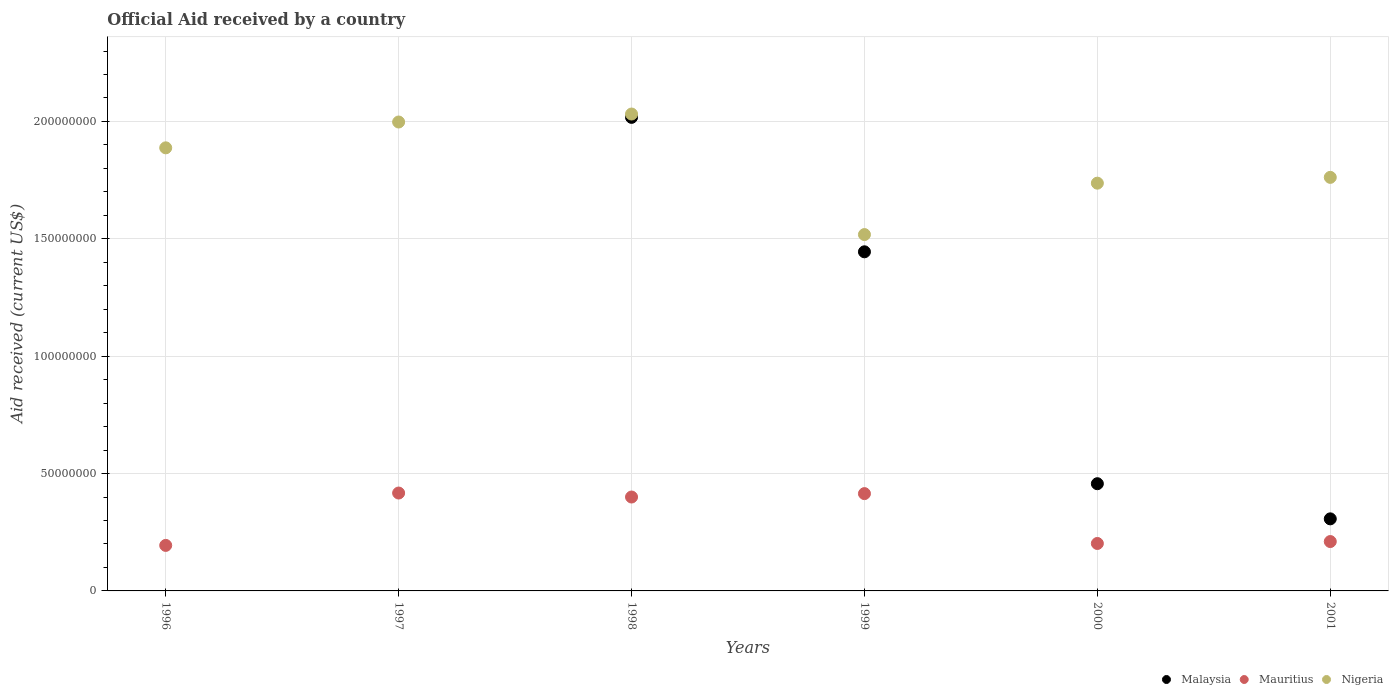Is the number of dotlines equal to the number of legend labels?
Make the answer very short. No. What is the net official aid received in Malaysia in 1998?
Provide a short and direct response. 2.02e+08. Across all years, what is the maximum net official aid received in Malaysia?
Provide a succinct answer. 2.02e+08. Across all years, what is the minimum net official aid received in Malaysia?
Make the answer very short. 0. What is the total net official aid received in Nigeria in the graph?
Give a very brief answer. 1.09e+09. What is the difference between the net official aid received in Malaysia in 1998 and that in 2000?
Ensure brevity in your answer.  1.56e+08. What is the difference between the net official aid received in Mauritius in 1998 and the net official aid received in Malaysia in 1997?
Give a very brief answer. 4.00e+07. What is the average net official aid received in Malaysia per year?
Your answer should be very brief. 7.04e+07. In the year 1999, what is the difference between the net official aid received in Malaysia and net official aid received in Nigeria?
Your answer should be very brief. -7.34e+06. What is the ratio of the net official aid received in Mauritius in 2000 to that in 2001?
Give a very brief answer. 0.96. Is the difference between the net official aid received in Malaysia in 2000 and 2001 greater than the difference between the net official aid received in Nigeria in 2000 and 2001?
Your answer should be very brief. Yes. What is the difference between the highest and the second highest net official aid received in Malaysia?
Provide a succinct answer. 5.73e+07. What is the difference between the highest and the lowest net official aid received in Mauritius?
Provide a short and direct response. 2.23e+07. Is the sum of the net official aid received in Nigeria in 1998 and 2000 greater than the maximum net official aid received in Mauritius across all years?
Make the answer very short. Yes. Does the net official aid received in Mauritius monotonically increase over the years?
Provide a succinct answer. No. How many dotlines are there?
Offer a very short reply. 3. What is the difference between two consecutive major ticks on the Y-axis?
Ensure brevity in your answer.  5.00e+07. Are the values on the major ticks of Y-axis written in scientific E-notation?
Offer a very short reply. No. What is the title of the graph?
Offer a terse response. Official Aid received by a country. Does "Chile" appear as one of the legend labels in the graph?
Offer a terse response. No. What is the label or title of the X-axis?
Your answer should be compact. Years. What is the label or title of the Y-axis?
Provide a short and direct response. Aid received (current US$). What is the Aid received (current US$) in Malaysia in 1996?
Keep it short and to the point. 0. What is the Aid received (current US$) of Mauritius in 1996?
Ensure brevity in your answer.  1.94e+07. What is the Aid received (current US$) of Nigeria in 1996?
Offer a terse response. 1.89e+08. What is the Aid received (current US$) in Mauritius in 1997?
Your answer should be compact. 4.17e+07. What is the Aid received (current US$) of Nigeria in 1997?
Provide a short and direct response. 2.00e+08. What is the Aid received (current US$) in Malaysia in 1998?
Your response must be concise. 2.02e+08. What is the Aid received (current US$) of Mauritius in 1998?
Provide a succinct answer. 4.00e+07. What is the Aid received (current US$) in Nigeria in 1998?
Provide a short and direct response. 2.03e+08. What is the Aid received (current US$) of Malaysia in 1999?
Your answer should be very brief. 1.44e+08. What is the Aid received (current US$) in Mauritius in 1999?
Keep it short and to the point. 4.14e+07. What is the Aid received (current US$) in Nigeria in 1999?
Offer a terse response. 1.52e+08. What is the Aid received (current US$) in Malaysia in 2000?
Provide a short and direct response. 4.57e+07. What is the Aid received (current US$) of Mauritius in 2000?
Offer a very short reply. 2.02e+07. What is the Aid received (current US$) in Nigeria in 2000?
Your answer should be compact. 1.74e+08. What is the Aid received (current US$) of Malaysia in 2001?
Offer a terse response. 3.07e+07. What is the Aid received (current US$) in Mauritius in 2001?
Make the answer very short. 2.10e+07. What is the Aid received (current US$) in Nigeria in 2001?
Ensure brevity in your answer.  1.76e+08. Across all years, what is the maximum Aid received (current US$) in Malaysia?
Your answer should be compact. 2.02e+08. Across all years, what is the maximum Aid received (current US$) of Mauritius?
Ensure brevity in your answer.  4.17e+07. Across all years, what is the maximum Aid received (current US$) in Nigeria?
Provide a short and direct response. 2.03e+08. Across all years, what is the minimum Aid received (current US$) in Malaysia?
Ensure brevity in your answer.  0. Across all years, what is the minimum Aid received (current US$) of Mauritius?
Make the answer very short. 1.94e+07. Across all years, what is the minimum Aid received (current US$) in Nigeria?
Your answer should be compact. 1.52e+08. What is the total Aid received (current US$) in Malaysia in the graph?
Your answer should be compact. 4.23e+08. What is the total Aid received (current US$) of Mauritius in the graph?
Offer a very short reply. 1.84e+08. What is the total Aid received (current US$) in Nigeria in the graph?
Give a very brief answer. 1.09e+09. What is the difference between the Aid received (current US$) in Mauritius in 1996 and that in 1997?
Give a very brief answer. -2.23e+07. What is the difference between the Aid received (current US$) in Nigeria in 1996 and that in 1997?
Ensure brevity in your answer.  -1.10e+07. What is the difference between the Aid received (current US$) in Mauritius in 1996 and that in 1998?
Offer a very short reply. -2.06e+07. What is the difference between the Aid received (current US$) of Nigeria in 1996 and that in 1998?
Provide a succinct answer. -1.44e+07. What is the difference between the Aid received (current US$) in Mauritius in 1996 and that in 1999?
Provide a short and direct response. -2.21e+07. What is the difference between the Aid received (current US$) of Nigeria in 1996 and that in 1999?
Your answer should be compact. 3.70e+07. What is the difference between the Aid received (current US$) of Mauritius in 1996 and that in 2000?
Provide a succinct answer. -8.20e+05. What is the difference between the Aid received (current US$) in Nigeria in 1996 and that in 2000?
Your answer should be very brief. 1.50e+07. What is the difference between the Aid received (current US$) in Mauritius in 1996 and that in 2001?
Offer a terse response. -1.64e+06. What is the difference between the Aid received (current US$) of Nigeria in 1996 and that in 2001?
Ensure brevity in your answer.  1.26e+07. What is the difference between the Aid received (current US$) of Mauritius in 1997 and that in 1998?
Your response must be concise. 1.70e+06. What is the difference between the Aid received (current US$) in Nigeria in 1997 and that in 1998?
Give a very brief answer. -3.40e+06. What is the difference between the Aid received (current US$) of Mauritius in 1997 and that in 1999?
Your response must be concise. 2.50e+05. What is the difference between the Aid received (current US$) in Nigeria in 1997 and that in 1999?
Provide a short and direct response. 4.80e+07. What is the difference between the Aid received (current US$) of Mauritius in 1997 and that in 2000?
Your response must be concise. 2.15e+07. What is the difference between the Aid received (current US$) of Nigeria in 1997 and that in 2000?
Your response must be concise. 2.60e+07. What is the difference between the Aid received (current US$) of Mauritius in 1997 and that in 2001?
Make the answer very short. 2.07e+07. What is the difference between the Aid received (current US$) of Nigeria in 1997 and that in 2001?
Provide a succinct answer. 2.36e+07. What is the difference between the Aid received (current US$) of Malaysia in 1998 and that in 1999?
Provide a short and direct response. 5.73e+07. What is the difference between the Aid received (current US$) of Mauritius in 1998 and that in 1999?
Ensure brevity in your answer.  -1.45e+06. What is the difference between the Aid received (current US$) of Nigeria in 1998 and that in 1999?
Keep it short and to the point. 5.14e+07. What is the difference between the Aid received (current US$) in Malaysia in 1998 and that in 2000?
Keep it short and to the point. 1.56e+08. What is the difference between the Aid received (current US$) of Mauritius in 1998 and that in 2000?
Your response must be concise. 1.98e+07. What is the difference between the Aid received (current US$) of Nigeria in 1998 and that in 2000?
Your response must be concise. 2.94e+07. What is the difference between the Aid received (current US$) of Malaysia in 1998 and that in 2001?
Your response must be concise. 1.71e+08. What is the difference between the Aid received (current US$) in Mauritius in 1998 and that in 2001?
Provide a succinct answer. 1.90e+07. What is the difference between the Aid received (current US$) in Nigeria in 1998 and that in 2001?
Ensure brevity in your answer.  2.70e+07. What is the difference between the Aid received (current US$) of Malaysia in 1999 and that in 2000?
Your answer should be compact. 9.88e+07. What is the difference between the Aid received (current US$) in Mauritius in 1999 and that in 2000?
Your answer should be very brief. 2.12e+07. What is the difference between the Aid received (current US$) of Nigeria in 1999 and that in 2000?
Keep it short and to the point. -2.19e+07. What is the difference between the Aid received (current US$) in Malaysia in 1999 and that in 2001?
Make the answer very short. 1.14e+08. What is the difference between the Aid received (current US$) of Mauritius in 1999 and that in 2001?
Give a very brief answer. 2.04e+07. What is the difference between the Aid received (current US$) of Nigeria in 1999 and that in 2001?
Your answer should be compact. -2.44e+07. What is the difference between the Aid received (current US$) of Malaysia in 2000 and that in 2001?
Give a very brief answer. 1.50e+07. What is the difference between the Aid received (current US$) of Mauritius in 2000 and that in 2001?
Keep it short and to the point. -8.20e+05. What is the difference between the Aid received (current US$) in Nigeria in 2000 and that in 2001?
Your response must be concise. -2.47e+06. What is the difference between the Aid received (current US$) in Mauritius in 1996 and the Aid received (current US$) in Nigeria in 1997?
Your answer should be compact. -1.80e+08. What is the difference between the Aid received (current US$) in Mauritius in 1996 and the Aid received (current US$) in Nigeria in 1998?
Keep it short and to the point. -1.84e+08. What is the difference between the Aid received (current US$) of Mauritius in 1996 and the Aid received (current US$) of Nigeria in 1999?
Ensure brevity in your answer.  -1.32e+08. What is the difference between the Aid received (current US$) in Mauritius in 1996 and the Aid received (current US$) in Nigeria in 2000?
Your response must be concise. -1.54e+08. What is the difference between the Aid received (current US$) in Mauritius in 1996 and the Aid received (current US$) in Nigeria in 2001?
Make the answer very short. -1.57e+08. What is the difference between the Aid received (current US$) in Mauritius in 1997 and the Aid received (current US$) in Nigeria in 1998?
Give a very brief answer. -1.61e+08. What is the difference between the Aid received (current US$) in Mauritius in 1997 and the Aid received (current US$) in Nigeria in 1999?
Your answer should be compact. -1.10e+08. What is the difference between the Aid received (current US$) of Mauritius in 1997 and the Aid received (current US$) of Nigeria in 2000?
Your answer should be very brief. -1.32e+08. What is the difference between the Aid received (current US$) of Mauritius in 1997 and the Aid received (current US$) of Nigeria in 2001?
Your answer should be very brief. -1.34e+08. What is the difference between the Aid received (current US$) of Malaysia in 1998 and the Aid received (current US$) of Mauritius in 1999?
Offer a very short reply. 1.60e+08. What is the difference between the Aid received (current US$) of Malaysia in 1998 and the Aid received (current US$) of Nigeria in 1999?
Your answer should be compact. 4.99e+07. What is the difference between the Aid received (current US$) in Mauritius in 1998 and the Aid received (current US$) in Nigeria in 1999?
Give a very brief answer. -1.12e+08. What is the difference between the Aid received (current US$) in Malaysia in 1998 and the Aid received (current US$) in Mauritius in 2000?
Your answer should be compact. 1.82e+08. What is the difference between the Aid received (current US$) of Malaysia in 1998 and the Aid received (current US$) of Nigeria in 2000?
Ensure brevity in your answer.  2.80e+07. What is the difference between the Aid received (current US$) in Mauritius in 1998 and the Aid received (current US$) in Nigeria in 2000?
Provide a short and direct response. -1.34e+08. What is the difference between the Aid received (current US$) in Malaysia in 1998 and the Aid received (current US$) in Mauritius in 2001?
Provide a short and direct response. 1.81e+08. What is the difference between the Aid received (current US$) in Malaysia in 1998 and the Aid received (current US$) in Nigeria in 2001?
Your response must be concise. 2.56e+07. What is the difference between the Aid received (current US$) in Mauritius in 1998 and the Aid received (current US$) in Nigeria in 2001?
Your answer should be very brief. -1.36e+08. What is the difference between the Aid received (current US$) of Malaysia in 1999 and the Aid received (current US$) of Mauritius in 2000?
Make the answer very short. 1.24e+08. What is the difference between the Aid received (current US$) of Malaysia in 1999 and the Aid received (current US$) of Nigeria in 2000?
Ensure brevity in your answer.  -2.92e+07. What is the difference between the Aid received (current US$) of Mauritius in 1999 and the Aid received (current US$) of Nigeria in 2000?
Provide a short and direct response. -1.32e+08. What is the difference between the Aid received (current US$) of Malaysia in 1999 and the Aid received (current US$) of Mauritius in 2001?
Your answer should be very brief. 1.23e+08. What is the difference between the Aid received (current US$) in Malaysia in 1999 and the Aid received (current US$) in Nigeria in 2001?
Offer a terse response. -3.17e+07. What is the difference between the Aid received (current US$) in Mauritius in 1999 and the Aid received (current US$) in Nigeria in 2001?
Ensure brevity in your answer.  -1.35e+08. What is the difference between the Aid received (current US$) in Malaysia in 2000 and the Aid received (current US$) in Mauritius in 2001?
Give a very brief answer. 2.46e+07. What is the difference between the Aid received (current US$) in Malaysia in 2000 and the Aid received (current US$) in Nigeria in 2001?
Your answer should be compact. -1.30e+08. What is the difference between the Aid received (current US$) in Mauritius in 2000 and the Aid received (current US$) in Nigeria in 2001?
Offer a terse response. -1.56e+08. What is the average Aid received (current US$) of Malaysia per year?
Give a very brief answer. 7.04e+07. What is the average Aid received (current US$) of Mauritius per year?
Provide a short and direct response. 3.06e+07. What is the average Aid received (current US$) of Nigeria per year?
Offer a terse response. 1.82e+08. In the year 1996, what is the difference between the Aid received (current US$) in Mauritius and Aid received (current US$) in Nigeria?
Your answer should be compact. -1.69e+08. In the year 1997, what is the difference between the Aid received (current US$) of Mauritius and Aid received (current US$) of Nigeria?
Your answer should be very brief. -1.58e+08. In the year 1998, what is the difference between the Aid received (current US$) of Malaysia and Aid received (current US$) of Mauritius?
Ensure brevity in your answer.  1.62e+08. In the year 1998, what is the difference between the Aid received (current US$) of Malaysia and Aid received (current US$) of Nigeria?
Ensure brevity in your answer.  -1.42e+06. In the year 1998, what is the difference between the Aid received (current US$) in Mauritius and Aid received (current US$) in Nigeria?
Your answer should be very brief. -1.63e+08. In the year 1999, what is the difference between the Aid received (current US$) of Malaysia and Aid received (current US$) of Mauritius?
Give a very brief answer. 1.03e+08. In the year 1999, what is the difference between the Aid received (current US$) in Malaysia and Aid received (current US$) in Nigeria?
Your response must be concise. -7.34e+06. In the year 1999, what is the difference between the Aid received (current US$) of Mauritius and Aid received (current US$) of Nigeria?
Your answer should be very brief. -1.10e+08. In the year 2000, what is the difference between the Aid received (current US$) in Malaysia and Aid received (current US$) in Mauritius?
Your answer should be compact. 2.55e+07. In the year 2000, what is the difference between the Aid received (current US$) in Malaysia and Aid received (current US$) in Nigeria?
Offer a very short reply. -1.28e+08. In the year 2000, what is the difference between the Aid received (current US$) of Mauritius and Aid received (current US$) of Nigeria?
Your answer should be compact. -1.53e+08. In the year 2001, what is the difference between the Aid received (current US$) in Malaysia and Aid received (current US$) in Mauritius?
Your response must be concise. 9.67e+06. In the year 2001, what is the difference between the Aid received (current US$) of Malaysia and Aid received (current US$) of Nigeria?
Offer a terse response. -1.45e+08. In the year 2001, what is the difference between the Aid received (current US$) of Mauritius and Aid received (current US$) of Nigeria?
Offer a terse response. -1.55e+08. What is the ratio of the Aid received (current US$) of Mauritius in 1996 to that in 1997?
Your answer should be compact. 0.47. What is the ratio of the Aid received (current US$) in Nigeria in 1996 to that in 1997?
Your answer should be very brief. 0.94. What is the ratio of the Aid received (current US$) of Mauritius in 1996 to that in 1998?
Offer a very short reply. 0.48. What is the ratio of the Aid received (current US$) of Nigeria in 1996 to that in 1998?
Your response must be concise. 0.93. What is the ratio of the Aid received (current US$) of Mauritius in 1996 to that in 1999?
Offer a very short reply. 0.47. What is the ratio of the Aid received (current US$) of Nigeria in 1996 to that in 1999?
Give a very brief answer. 1.24. What is the ratio of the Aid received (current US$) of Mauritius in 1996 to that in 2000?
Your answer should be compact. 0.96. What is the ratio of the Aid received (current US$) in Nigeria in 1996 to that in 2000?
Give a very brief answer. 1.09. What is the ratio of the Aid received (current US$) of Mauritius in 1996 to that in 2001?
Make the answer very short. 0.92. What is the ratio of the Aid received (current US$) of Nigeria in 1996 to that in 2001?
Provide a succinct answer. 1.07. What is the ratio of the Aid received (current US$) in Mauritius in 1997 to that in 1998?
Provide a succinct answer. 1.04. What is the ratio of the Aid received (current US$) of Nigeria in 1997 to that in 1998?
Give a very brief answer. 0.98. What is the ratio of the Aid received (current US$) in Mauritius in 1997 to that in 1999?
Your response must be concise. 1.01. What is the ratio of the Aid received (current US$) in Nigeria in 1997 to that in 1999?
Offer a terse response. 1.32. What is the ratio of the Aid received (current US$) in Mauritius in 1997 to that in 2000?
Your answer should be very brief. 2.06. What is the ratio of the Aid received (current US$) in Nigeria in 1997 to that in 2000?
Provide a succinct answer. 1.15. What is the ratio of the Aid received (current US$) of Mauritius in 1997 to that in 2001?
Make the answer very short. 1.98. What is the ratio of the Aid received (current US$) of Nigeria in 1997 to that in 2001?
Provide a succinct answer. 1.13. What is the ratio of the Aid received (current US$) of Malaysia in 1998 to that in 1999?
Make the answer very short. 1.4. What is the ratio of the Aid received (current US$) of Nigeria in 1998 to that in 1999?
Make the answer very short. 1.34. What is the ratio of the Aid received (current US$) of Malaysia in 1998 to that in 2000?
Your answer should be compact. 4.42. What is the ratio of the Aid received (current US$) in Mauritius in 1998 to that in 2000?
Make the answer very short. 1.98. What is the ratio of the Aid received (current US$) in Nigeria in 1998 to that in 2000?
Make the answer very short. 1.17. What is the ratio of the Aid received (current US$) in Malaysia in 1998 to that in 2001?
Ensure brevity in your answer.  6.57. What is the ratio of the Aid received (current US$) in Mauritius in 1998 to that in 2001?
Offer a very short reply. 1.9. What is the ratio of the Aid received (current US$) in Nigeria in 1998 to that in 2001?
Keep it short and to the point. 1.15. What is the ratio of the Aid received (current US$) of Malaysia in 1999 to that in 2000?
Provide a succinct answer. 3.16. What is the ratio of the Aid received (current US$) of Mauritius in 1999 to that in 2000?
Offer a terse response. 2.05. What is the ratio of the Aid received (current US$) in Nigeria in 1999 to that in 2000?
Your answer should be very brief. 0.87. What is the ratio of the Aid received (current US$) in Malaysia in 1999 to that in 2001?
Your response must be concise. 4.71. What is the ratio of the Aid received (current US$) in Mauritius in 1999 to that in 2001?
Offer a terse response. 1.97. What is the ratio of the Aid received (current US$) in Nigeria in 1999 to that in 2001?
Ensure brevity in your answer.  0.86. What is the ratio of the Aid received (current US$) of Malaysia in 2000 to that in 2001?
Your answer should be very brief. 1.49. What is the ratio of the Aid received (current US$) in Nigeria in 2000 to that in 2001?
Your response must be concise. 0.99. What is the difference between the highest and the second highest Aid received (current US$) of Malaysia?
Your answer should be very brief. 5.73e+07. What is the difference between the highest and the second highest Aid received (current US$) of Mauritius?
Your answer should be very brief. 2.50e+05. What is the difference between the highest and the second highest Aid received (current US$) of Nigeria?
Make the answer very short. 3.40e+06. What is the difference between the highest and the lowest Aid received (current US$) of Malaysia?
Make the answer very short. 2.02e+08. What is the difference between the highest and the lowest Aid received (current US$) of Mauritius?
Provide a succinct answer. 2.23e+07. What is the difference between the highest and the lowest Aid received (current US$) in Nigeria?
Your answer should be very brief. 5.14e+07. 